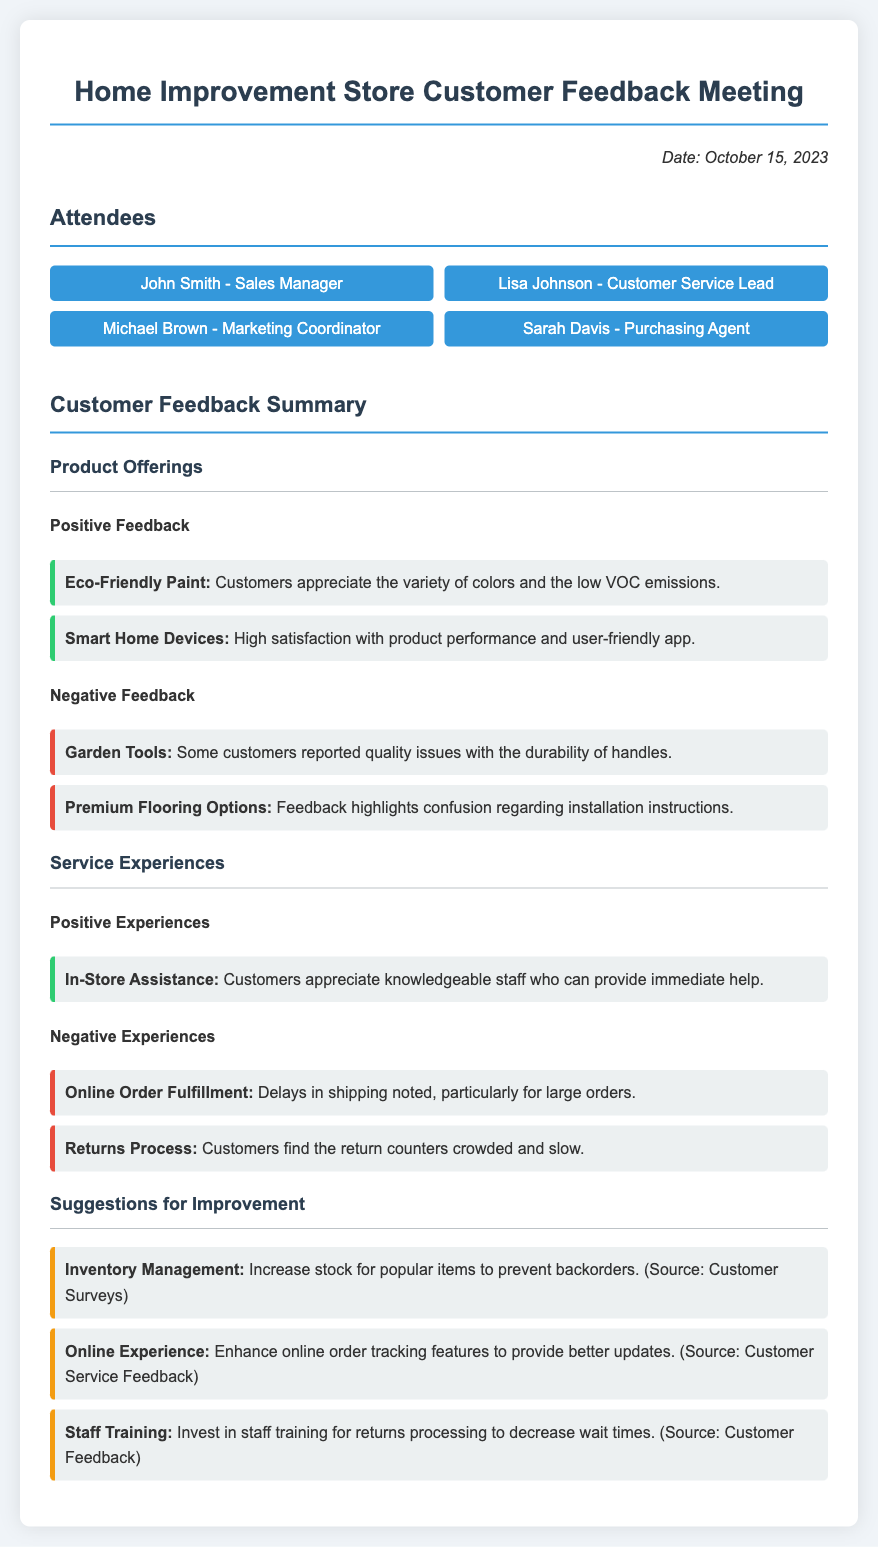What date was the meeting held? The meeting date is stated clearly in the document under the "Date" section.
Answer: October 15, 2023 Who provided feedback on the Smart Home Devices? The feedback for Smart Home Devices was noted in the Product Offerings section under Positive Feedback.
Answer: Customers What was highlighted as a negative feedback regarding Premium Flooring Options? The specific negative feedback is mentioned clearly in the document, indicating areas of concern regarding that product.
Answer: Confusion regarding installation instructions What suggestion relates to enhancing online order tracking features? This suggestion is one of those listed under Suggestions for Improvement, specifically addressing online service aspects.
Answer: Online Experience Which attendee holds the title of Customer Service Lead? The list of attendees is provided with their respective roles; this specific role can be directly identified.
Answer: Lisa Johnson How many positive experiences were noted for service? The number of positive experiences can be determined by counting the points listed under the Service Experiences section.
Answer: One What specific area was suggested for staff training? This is detailed in the Suggestions for Improvement section, addressing a specific training need within the store.
Answer: Returns processing 